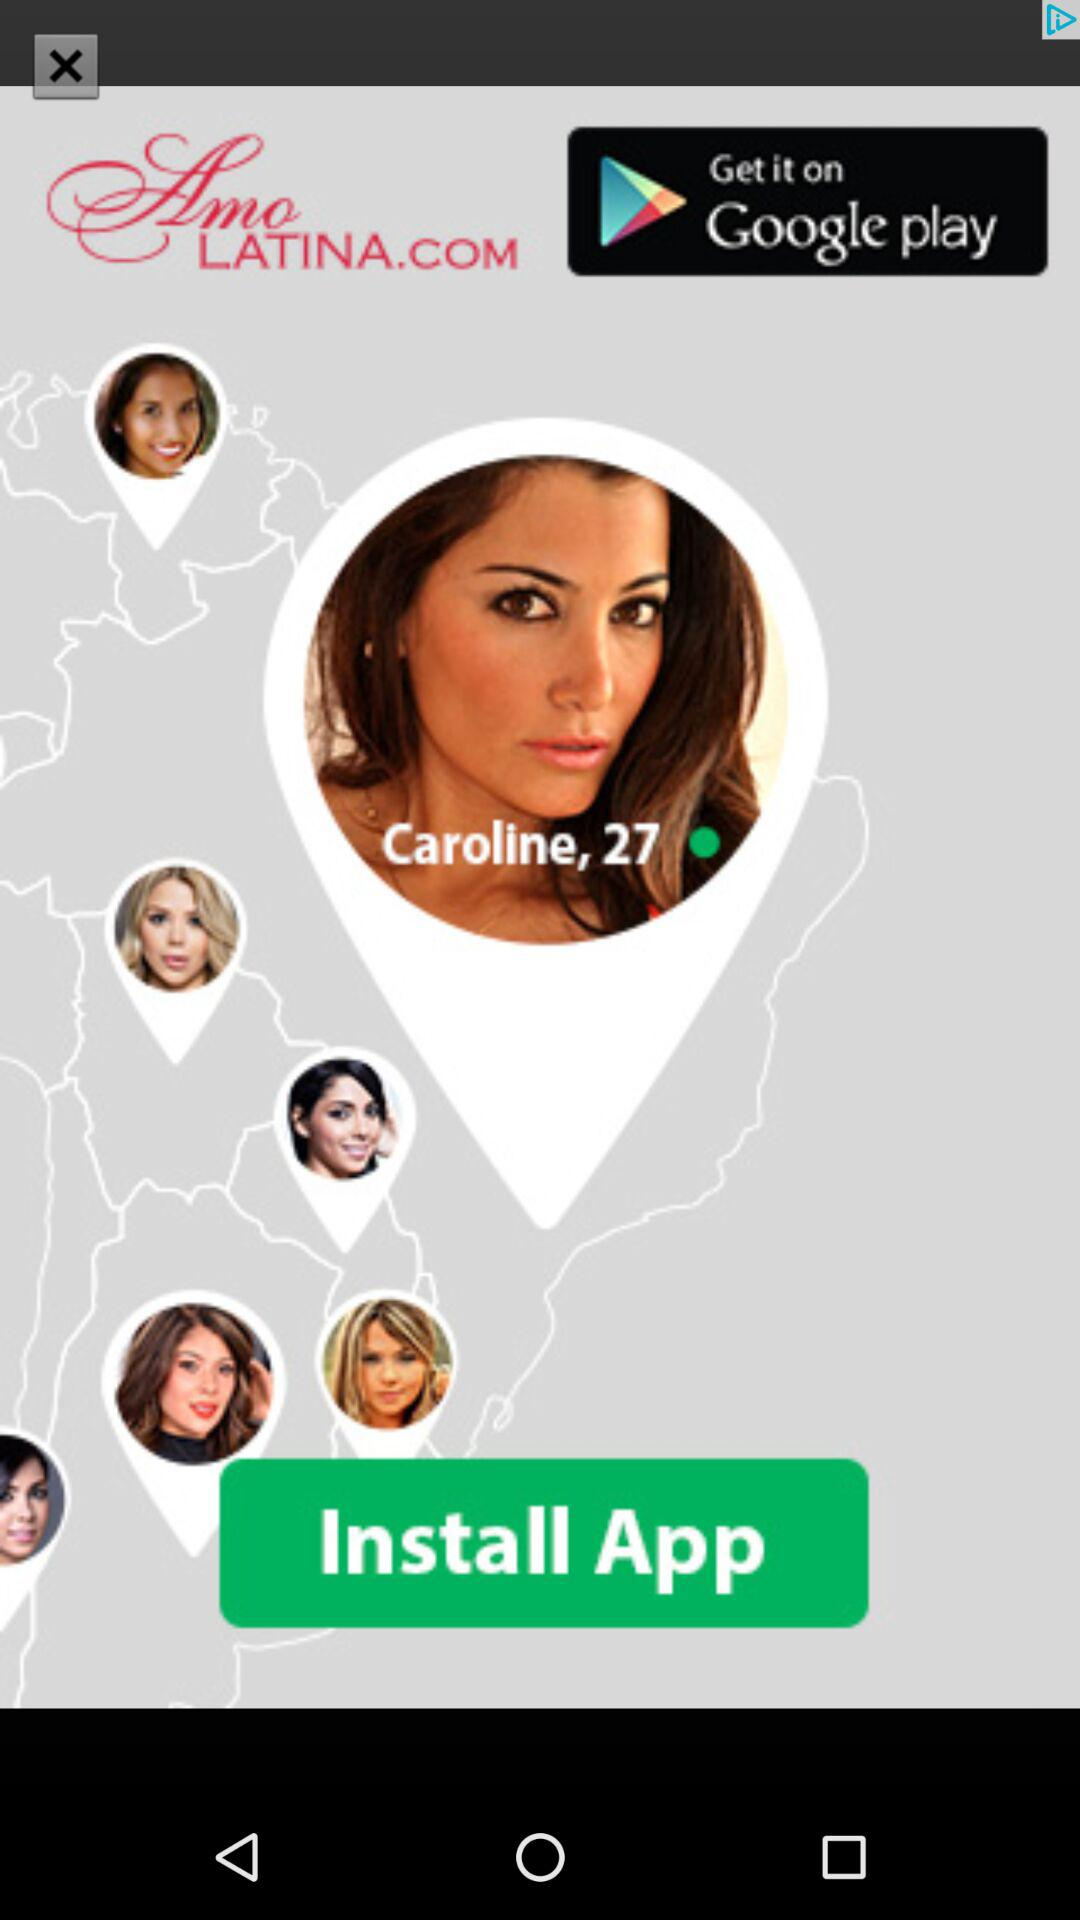What is the name of the application? The name of the application is "Amo LATINA.COM". 